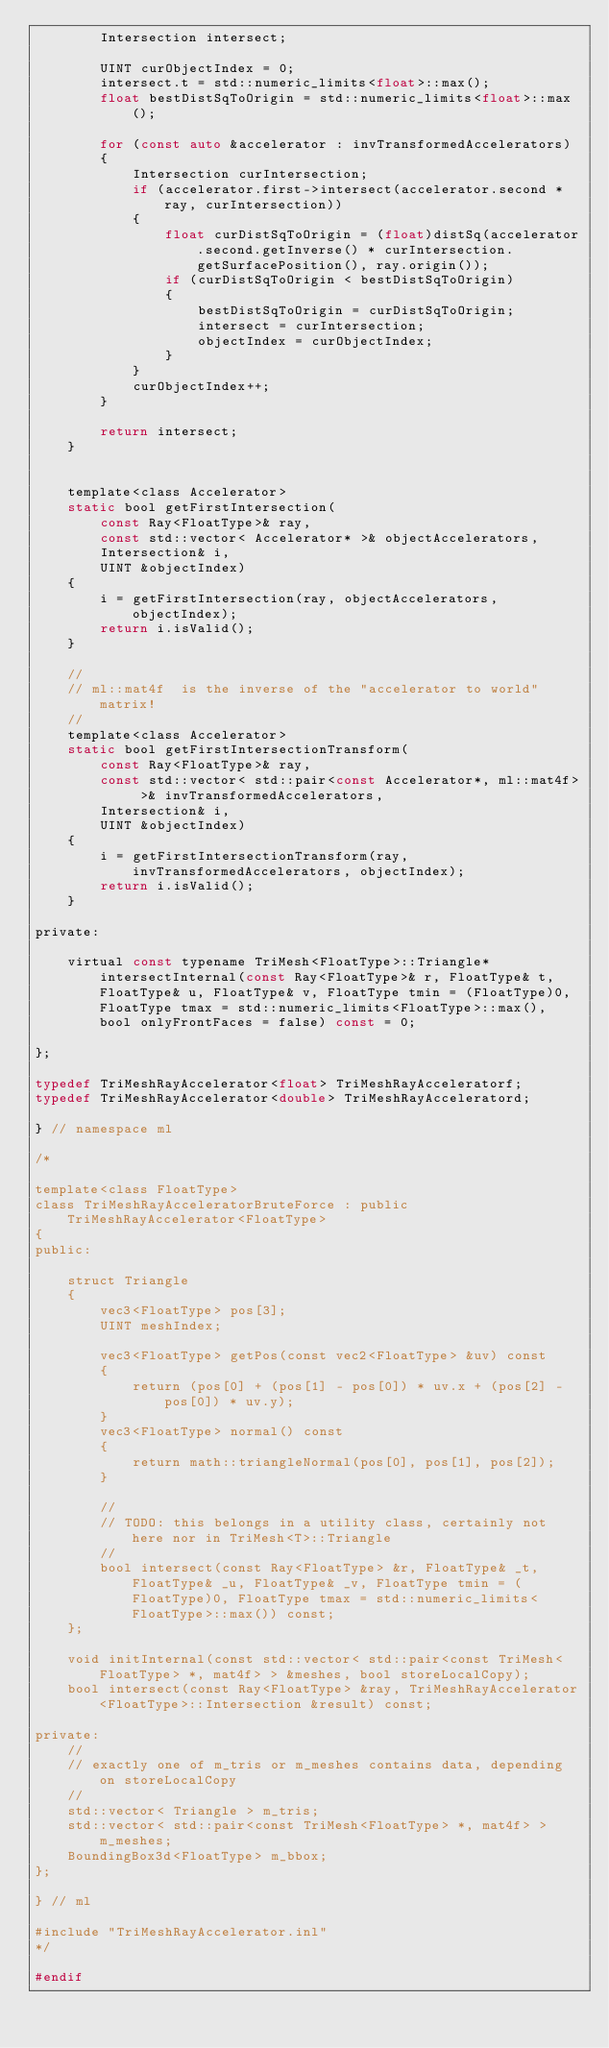<code> <loc_0><loc_0><loc_500><loc_500><_C_>        Intersection intersect;

        UINT curObjectIndex = 0;
        intersect.t = std::numeric_limits<float>::max();
        float bestDistSqToOrigin = std::numeric_limits<float>::max();

        for (const auto &accelerator : invTransformedAccelerators)
        {
            Intersection curIntersection;
            if (accelerator.first->intersect(accelerator.second * ray, curIntersection))
            {
                float curDistSqToOrigin = (float)distSq(accelerator.second.getInverse() * curIntersection.getSurfacePosition(), ray.origin());
                if (curDistSqToOrigin < bestDistSqToOrigin)
                {
                    bestDistSqToOrigin = curDistSqToOrigin;
                    intersect = curIntersection;
                    objectIndex = curObjectIndex;
                }
            }
            curObjectIndex++;
        }

        return intersect;
    }


	template<class Accelerator>
	static bool getFirstIntersection(
		const Ray<FloatType>& ray,  
		const std::vector< Accelerator* >& objectAccelerators,
		Intersection& i,
		UINT &objectIndex) 
	{
		i = getFirstIntersection(ray, objectAccelerators, objectIndex);
		return i.isValid();
	}

    //
    // ml::mat4f  is the inverse of the "accelerator to world" matrix!
    //
    template<class Accelerator>
    static bool getFirstIntersectionTransform(
        const Ray<FloatType>& ray,
        const std::vector< std::pair<const Accelerator*, ml::mat4f> >& invTransformedAccelerators,
        Intersection& i,
        UINT &objectIndex)
    {
        i = getFirstIntersectionTransform(ray, invTransformedAccelerators, objectIndex);
        return i.isValid();
    }

private:

	virtual const typename TriMesh<FloatType>::Triangle* intersectInternal(const Ray<FloatType>& r, FloatType& t, FloatType& u, FloatType& v, FloatType tmin = (FloatType)0, FloatType tmax = std::numeric_limits<FloatType>::max(), bool onlyFrontFaces = false) const = 0;

};

typedef TriMeshRayAccelerator<float> TriMeshRayAcceleratorf;
typedef TriMeshRayAccelerator<double> TriMeshRayAcceleratord;

} // namespace ml

/*

template<class FloatType>
class TriMeshRayAcceleratorBruteForce : public TriMeshRayAccelerator<FloatType>
{
public:

    struct Triangle
    {
        vec3<FloatType> pos[3];
        UINT meshIndex;

        vec3<FloatType> getPos(const vec2<FloatType> &uv) const
        {
            return (pos[0] + (pos[1] - pos[0]) * uv.x + (pos[2] - pos[0]) * uv.y);
        }
        vec3<FloatType> normal() const
        {
            return math::triangleNormal(pos[0], pos[1], pos[2]);
        }

        //
        // TODO: this belongs in a utility class, certainly not here nor in TriMesh<T>::Triangle
        //
        bool intersect(const Ray<FloatType> &r, FloatType& _t, FloatType& _u, FloatType& _v, FloatType tmin = (FloatType)0, FloatType tmax = std::numeric_limits<FloatType>::max()) const;
    };

    void initInternal(const std::vector< std::pair<const TriMesh<FloatType> *, mat4f> > &meshes, bool storeLocalCopy);
    bool intersect(const Ray<FloatType> &ray, TriMeshRayAccelerator<FloatType>::Intersection &result) const;

private:
    //
    // exactly one of m_tris or m_meshes contains data, depending on storeLocalCopy
    //
    std::vector< Triangle > m_tris;
    std::vector< std::pair<const TriMesh<FloatType> *, mat4f> > m_meshes;
    BoundingBox3d<FloatType> m_bbox;
};

} // ml

#include "TriMeshRayAccelerator.inl"
*/

#endif
</code> 